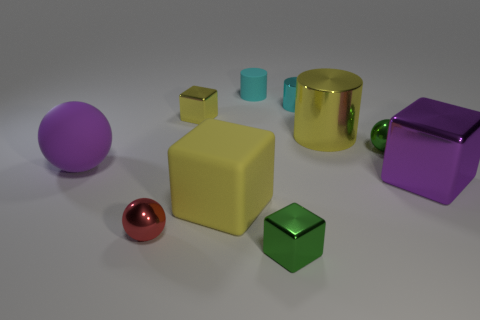What is the shape of the yellow thing that is the same size as the red metal object?
Your response must be concise. Cube. Are there the same number of large balls that are in front of the red ball and spheres that are to the left of the big yellow metal cylinder?
Your response must be concise. No. What is the size of the matte ball in front of the metal cube on the left side of the small green block?
Your response must be concise. Large. Are there any cylinders that have the same size as the purple metal cube?
Provide a short and direct response. Yes. What is the color of the tiny cylinder that is made of the same material as the large yellow cube?
Keep it short and to the point. Cyan. Are there fewer purple things than small blue cylinders?
Your response must be concise. No. What material is the big object that is in front of the big sphere and left of the cyan rubber object?
Offer a terse response. Rubber. Are there any big spheres left of the large rubber object on the right side of the tiny red thing?
Offer a terse response. Yes. What number of rubber objects are the same color as the tiny shiny cylinder?
Make the answer very short. 1. What material is the big thing that is the same color as the large metal cylinder?
Offer a terse response. Rubber. 